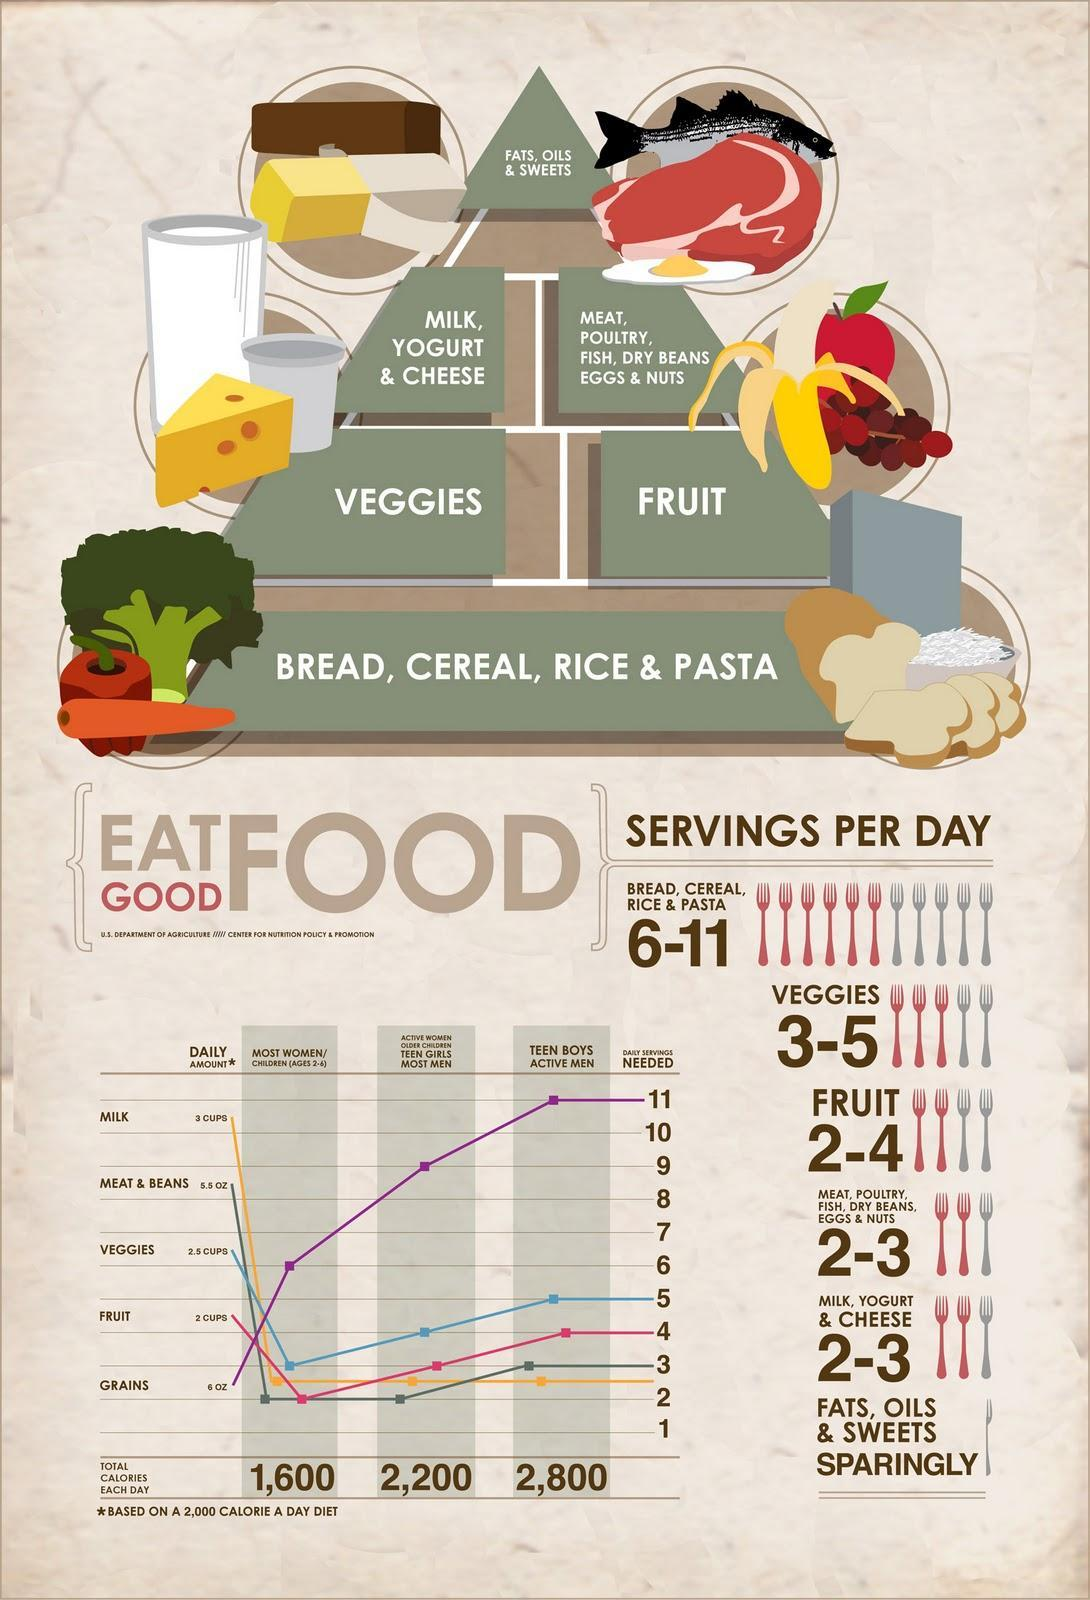What is the daily serving of meats and beans needed for most women and men?
Answer the question with a short phrase. 2 servings Which forms the top most layer of the food pyramids? Fats, Oils, Sweets What amount daily servings of milk needed for teen women and children 2-6? 2.5 servings What amount daily servings of veggies needed for women and children 2-6? 3 servings What amount daily servings of grains needed for teenage boys and men? 11 servings Which type of food should one eat most in the food pyramid, carbohydrates, fiber, proteins, or fats? ? carbohydrates Which food should be had in equal servings everyday for all genders and age groups? Milk 